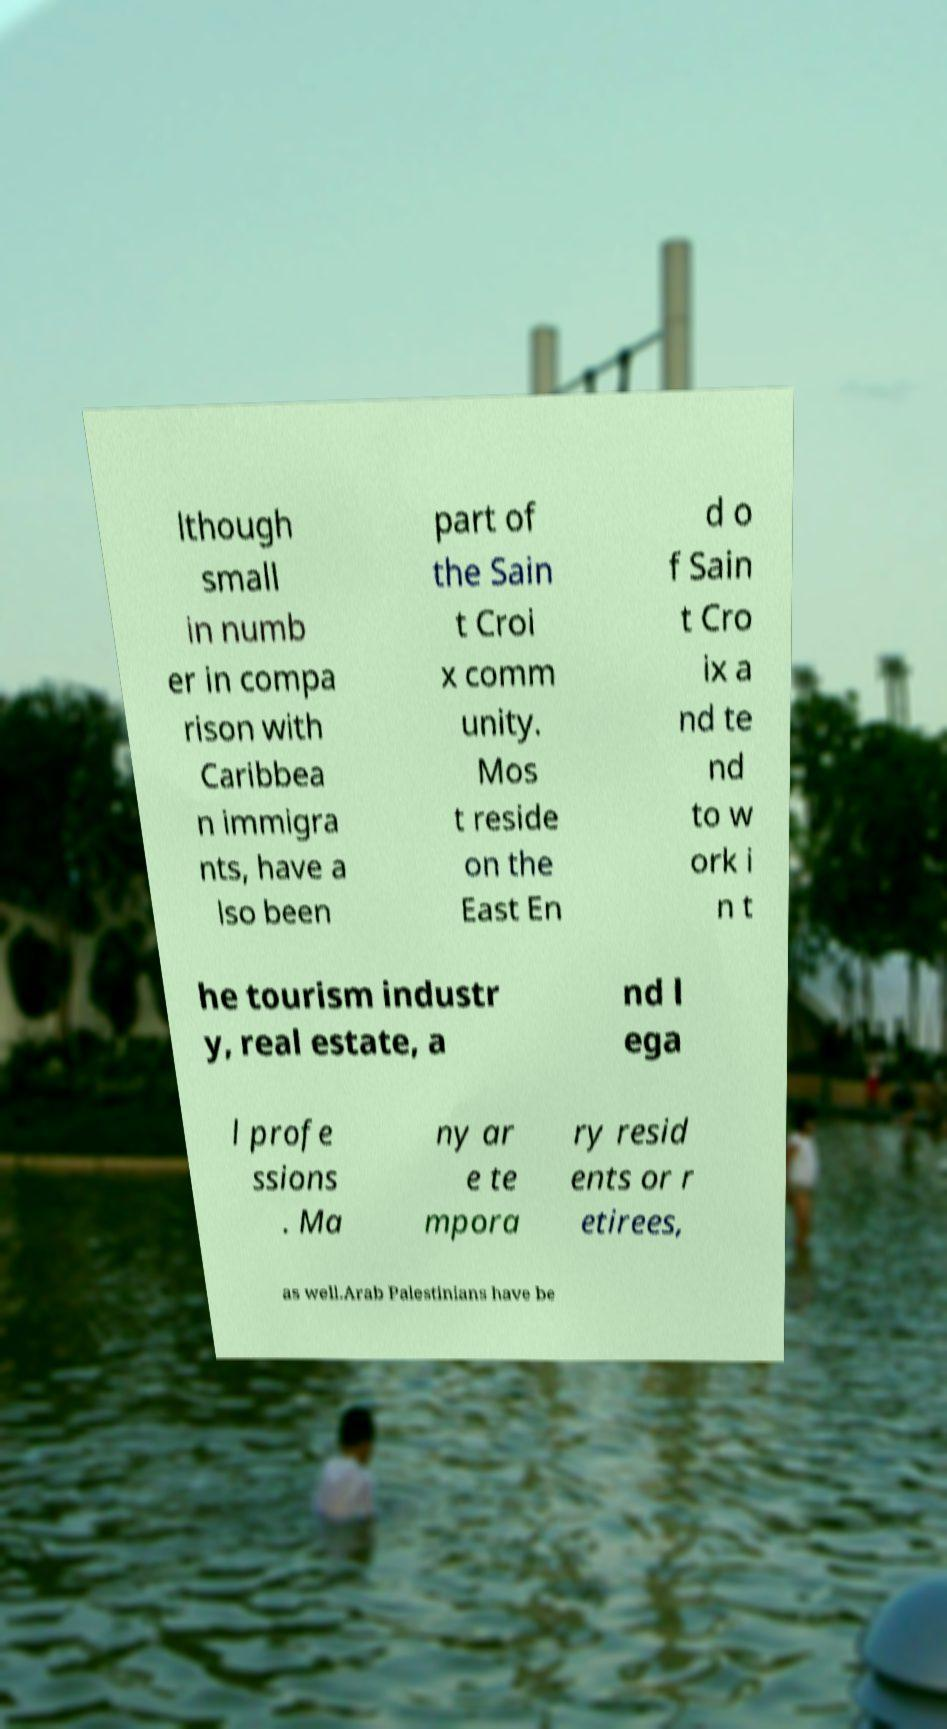Please identify and transcribe the text found in this image. lthough small in numb er in compa rison with Caribbea n immigra nts, have a lso been part of the Sain t Croi x comm unity. Mos t reside on the East En d o f Sain t Cro ix a nd te nd to w ork i n t he tourism industr y, real estate, a nd l ega l profe ssions . Ma ny ar e te mpora ry resid ents or r etirees, as well.Arab Palestinians have be 